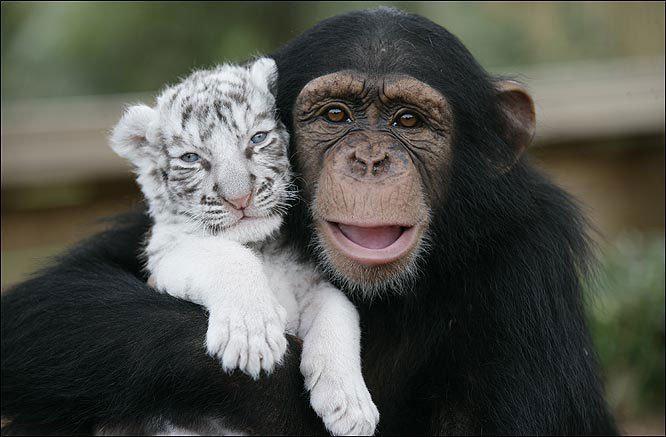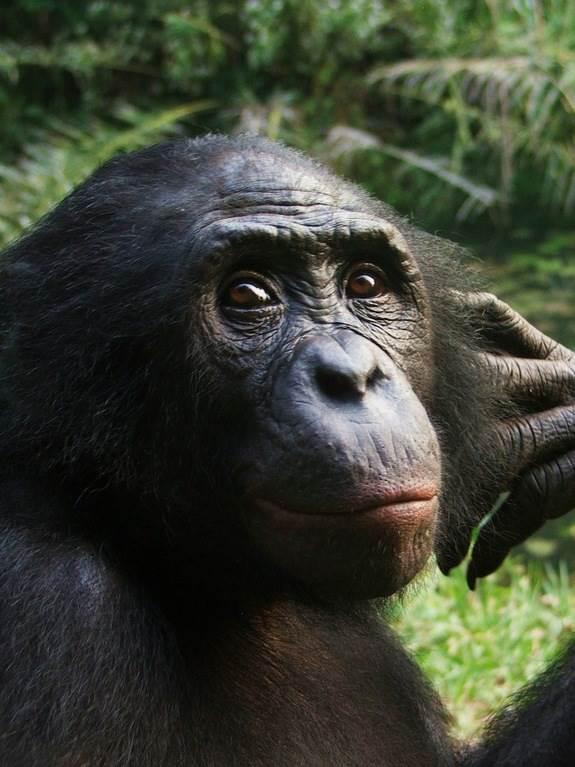The first image is the image on the left, the second image is the image on the right. Analyze the images presented: Is the assertion "there is a person in the image on the right" valid? Answer yes or no. No. The first image is the image on the left, the second image is the image on the right. Assess this claim about the two images: "An ape is holding a baby white tiger.". Correct or not? Answer yes or no. Yes. 